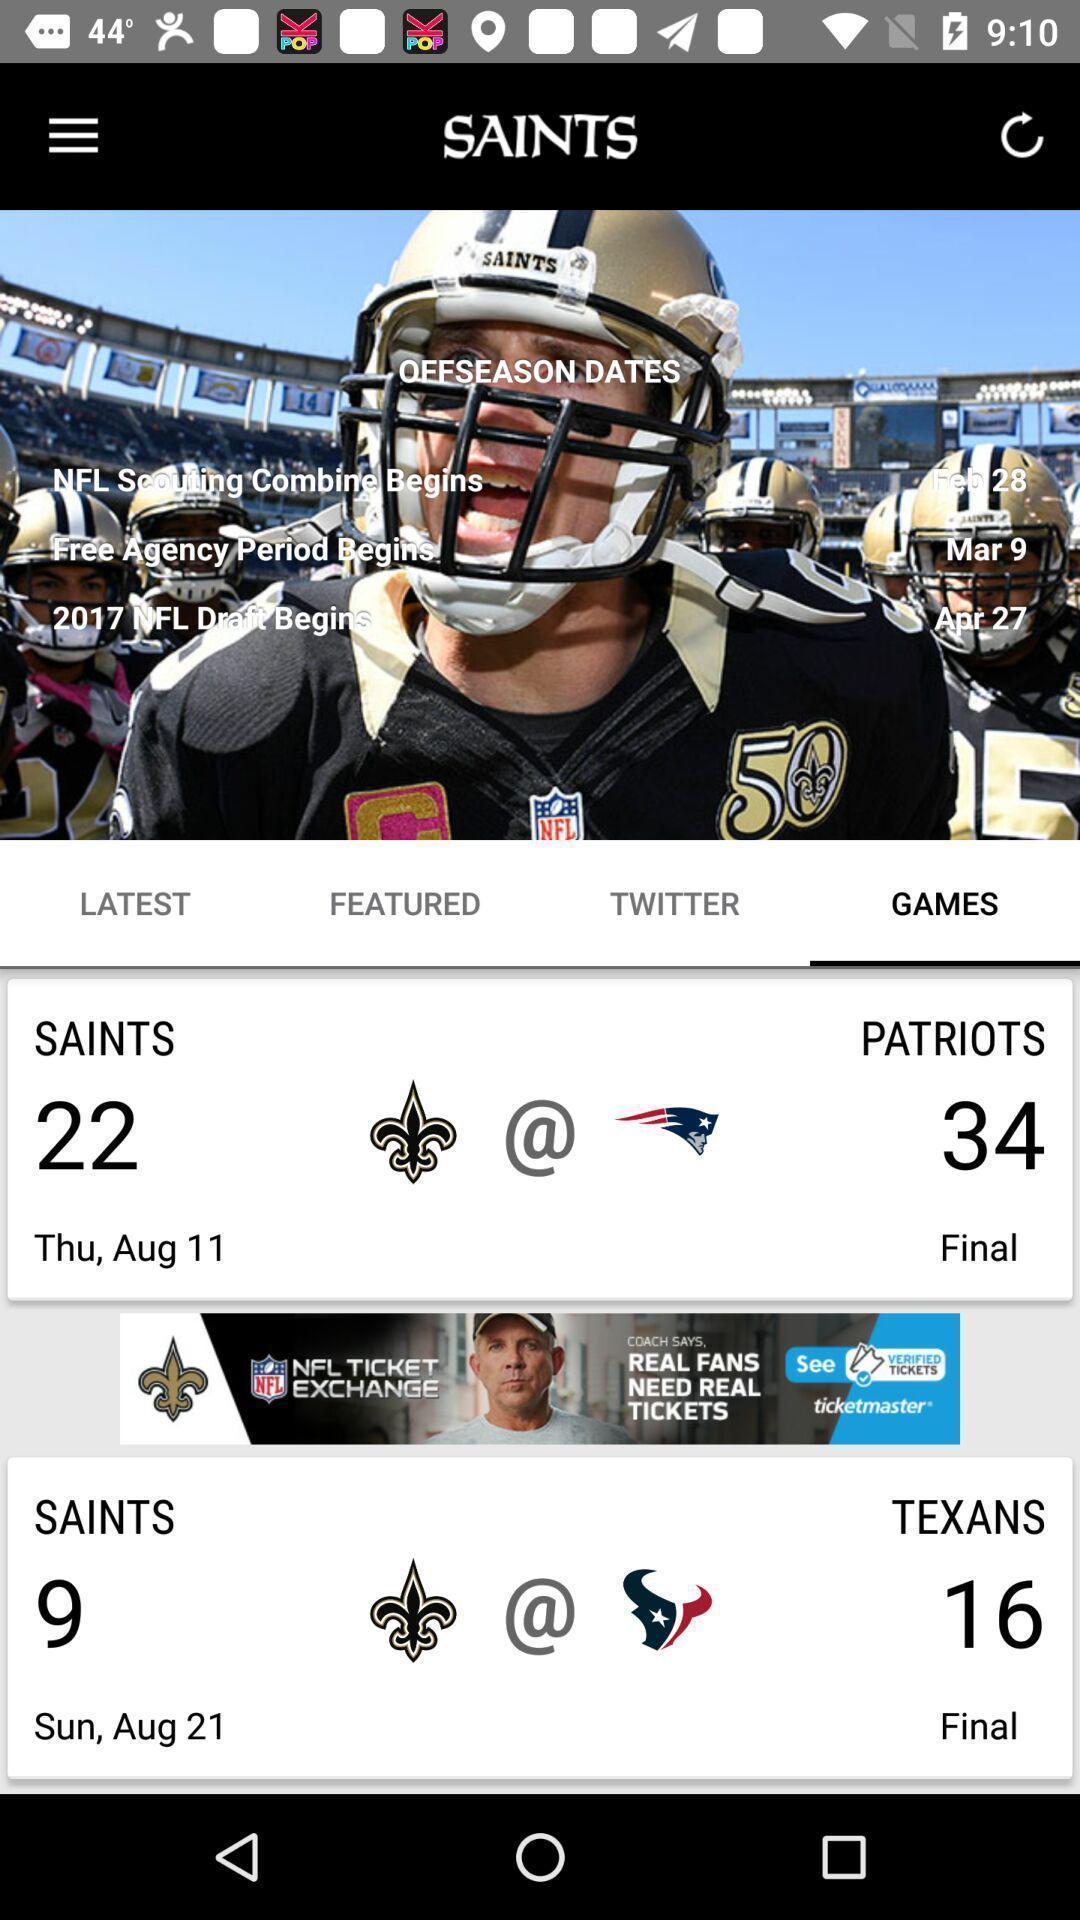Describe the key features of this screenshot. Page showing the matches schedule in game tab. 